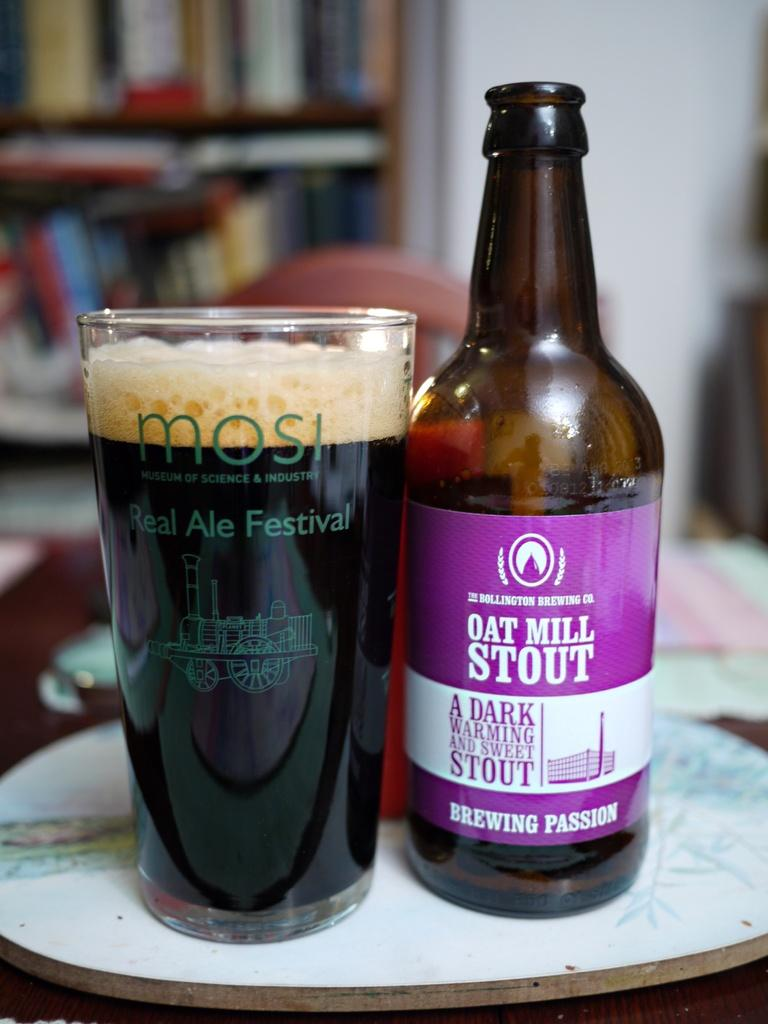<image>
Write a terse but informative summary of the picture. a bottle of oat mill stout a dark warming and sweet stout next to a glass filled of it 